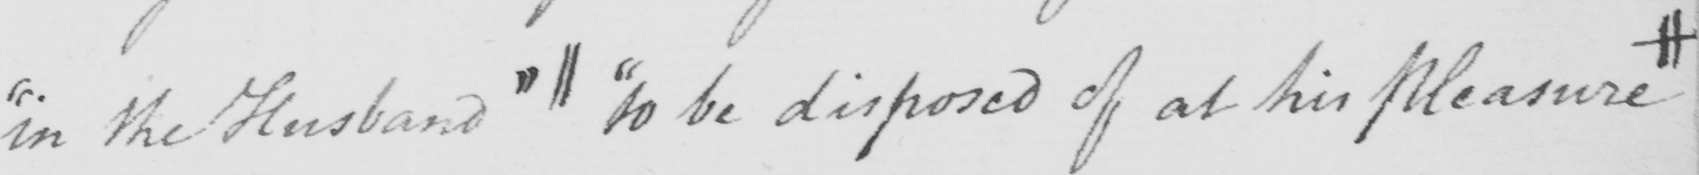Please provide the text content of this handwritten line. " in the Husband "  ||  " to be disposed of at his Pleasure # 